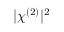<formula> <loc_0><loc_0><loc_500><loc_500>| \chi ^ { ( 2 ) } | ^ { 2 }</formula> 